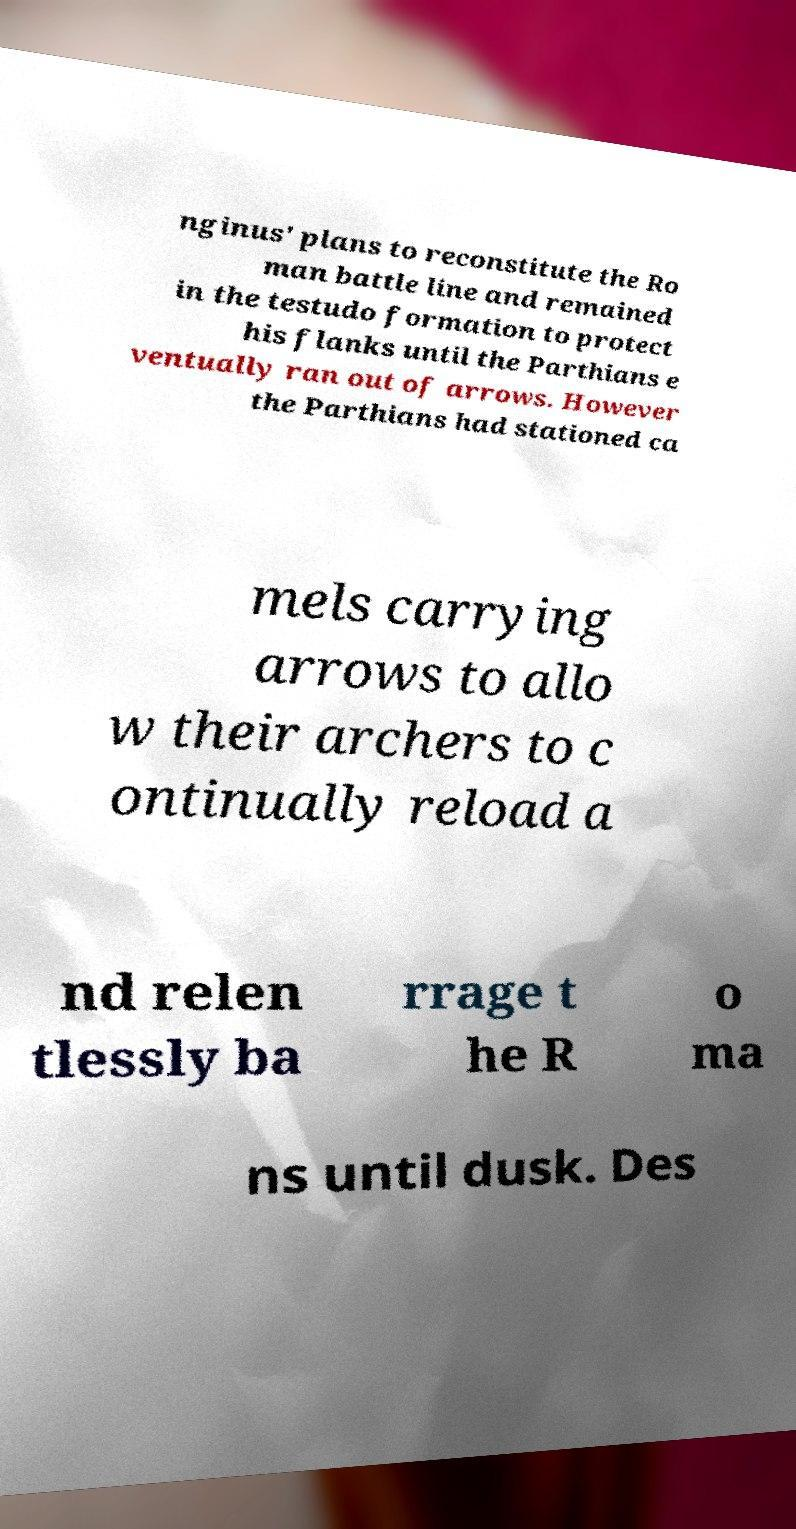There's text embedded in this image that I need extracted. Can you transcribe it verbatim? nginus' plans to reconstitute the Ro man battle line and remained in the testudo formation to protect his flanks until the Parthians e ventually ran out of arrows. However the Parthians had stationed ca mels carrying arrows to allo w their archers to c ontinually reload a nd relen tlessly ba rrage t he R o ma ns until dusk. Des 